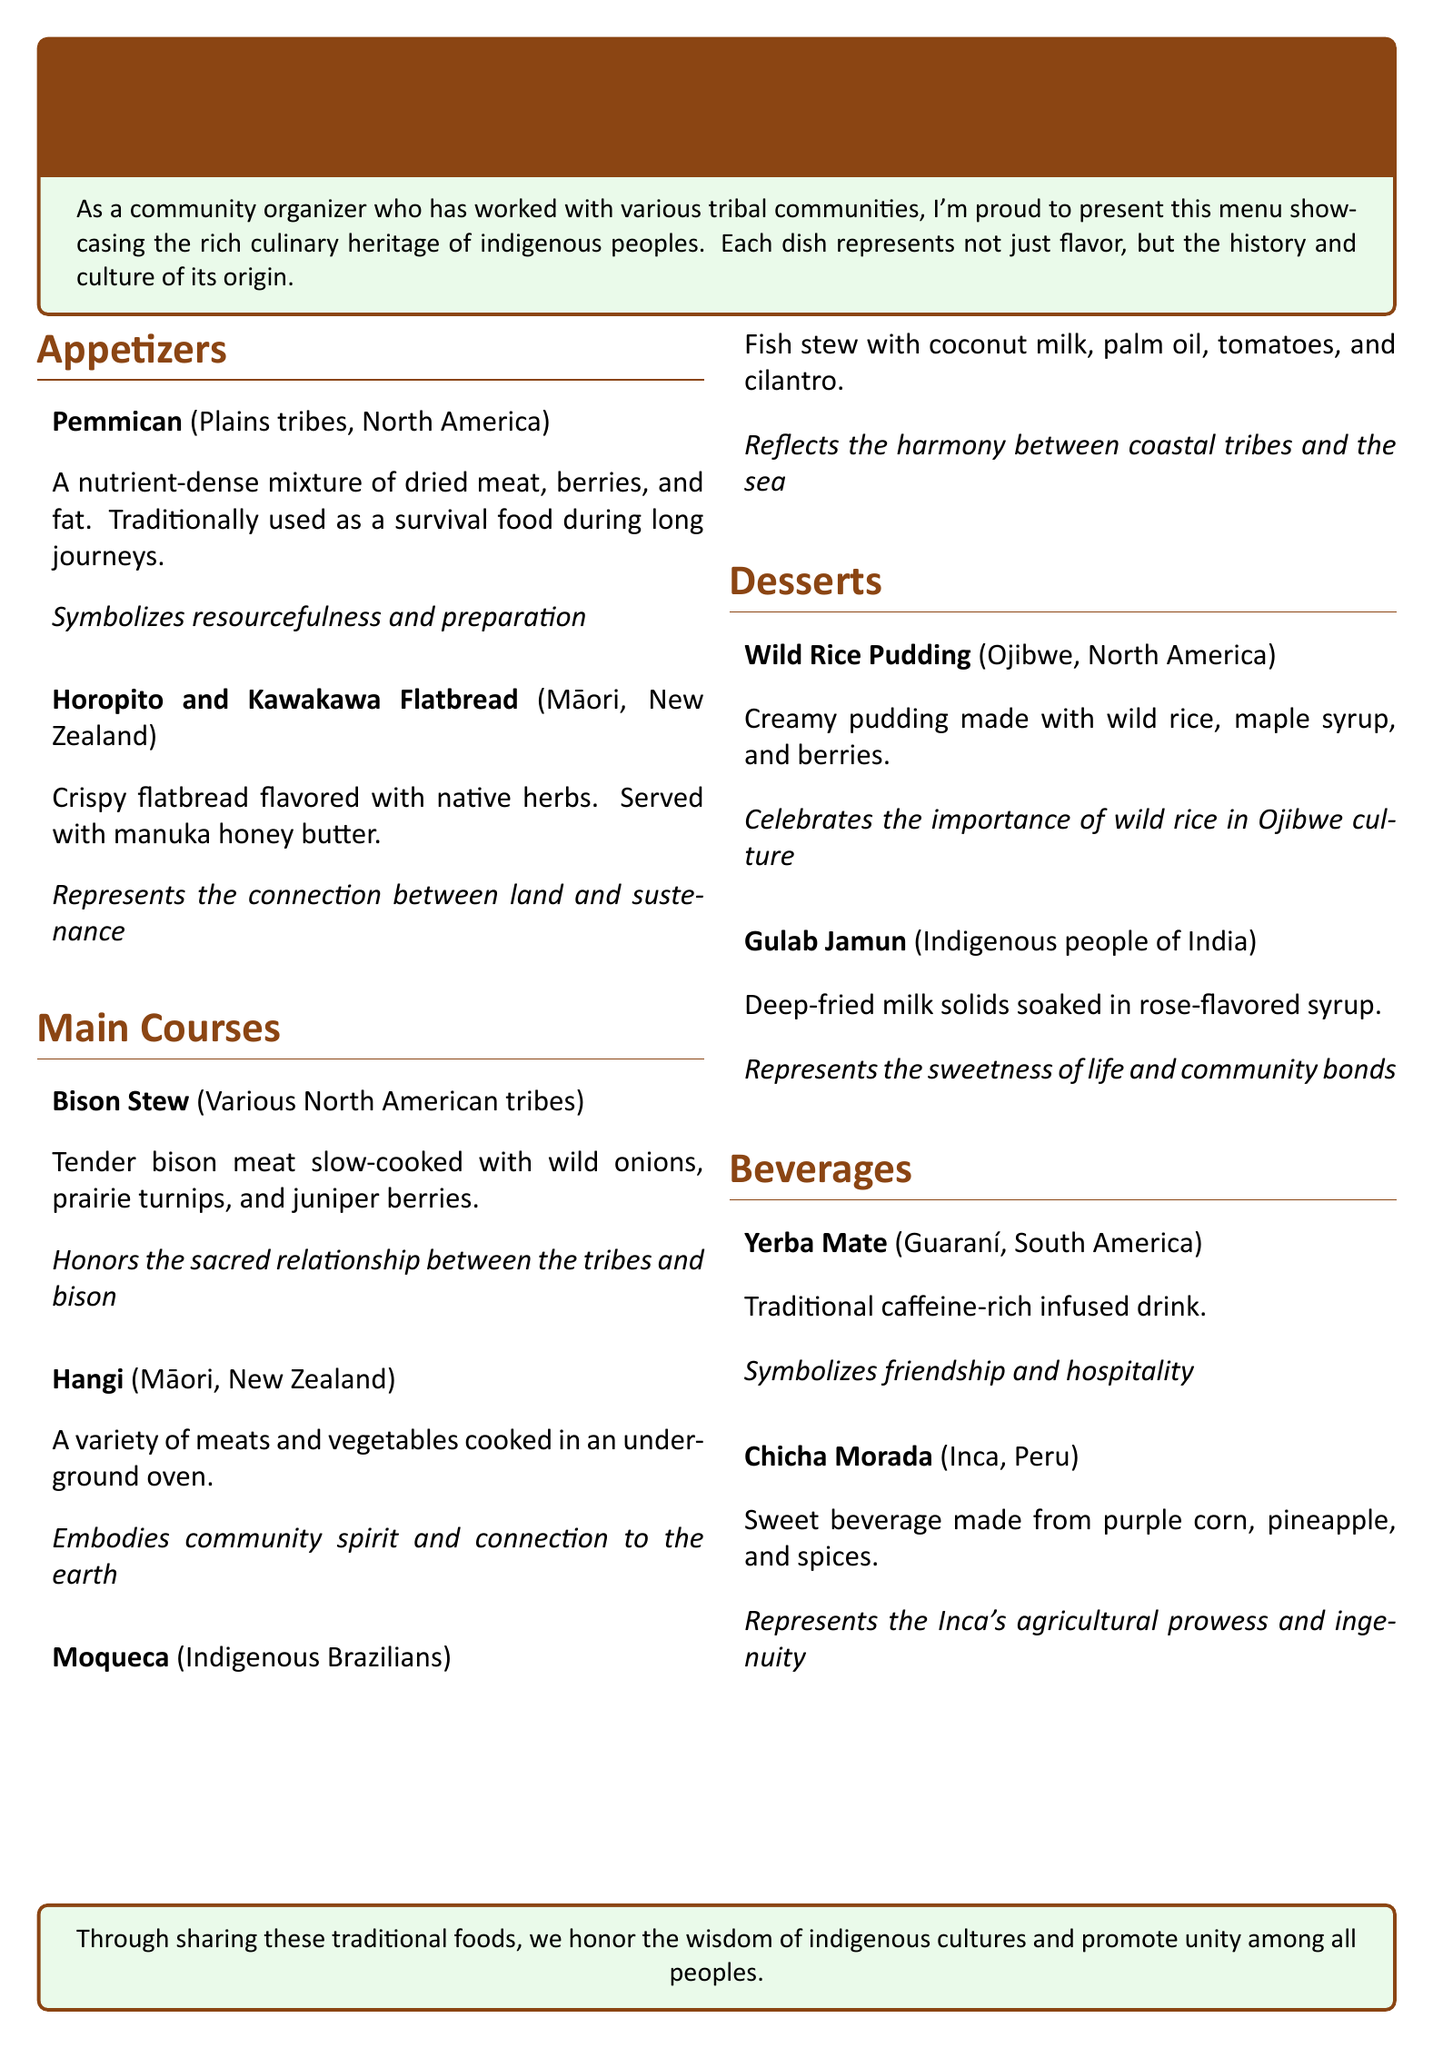What is the first appetizer listed? The first appetizer is the first item in the appetizers section, which is Pemican.
Answer: Pemmican What type of cuisine is the Hangi from? The Hangi is from the Māori community in New Zealand, as stated in the description.
Answer: Māori, New Zealand How is the Bison Stew prepared? The Bison Stew is described as being slow-cooked, which indicates the method of preparation.
Answer: Slow-cooked What significance does the Wild Rice Pudding hold? The cultural significance of the Wild Rice Pudding is highlighted in its description, which emphasizes wild rice's importance in Ojibwe culture.
Answer: Importance of wild rice in Ojibwe culture What beverage symbolizes friendship? The beverage that symbolizes friendship is mentioned in the beverage section and is specifically identified as Yerba Mate.
Answer: Yerba Mate How many main courses are listed in the menu? Counting the main courses section reveals that there are three distinct main courses presented.
Answer: Three What represents the connection between land and sustenance? In the appetizers section, the description indicates that Horopito and Kawakawa Flatbread symbolizes this connection.
Answer: Horopito and Kawakawa Flatbread What is the main ingredient in Chicha Morada? The description states that Chicha Morada is made primarily from purple corn, which is its main ingredient.
Answer: Purple corn 